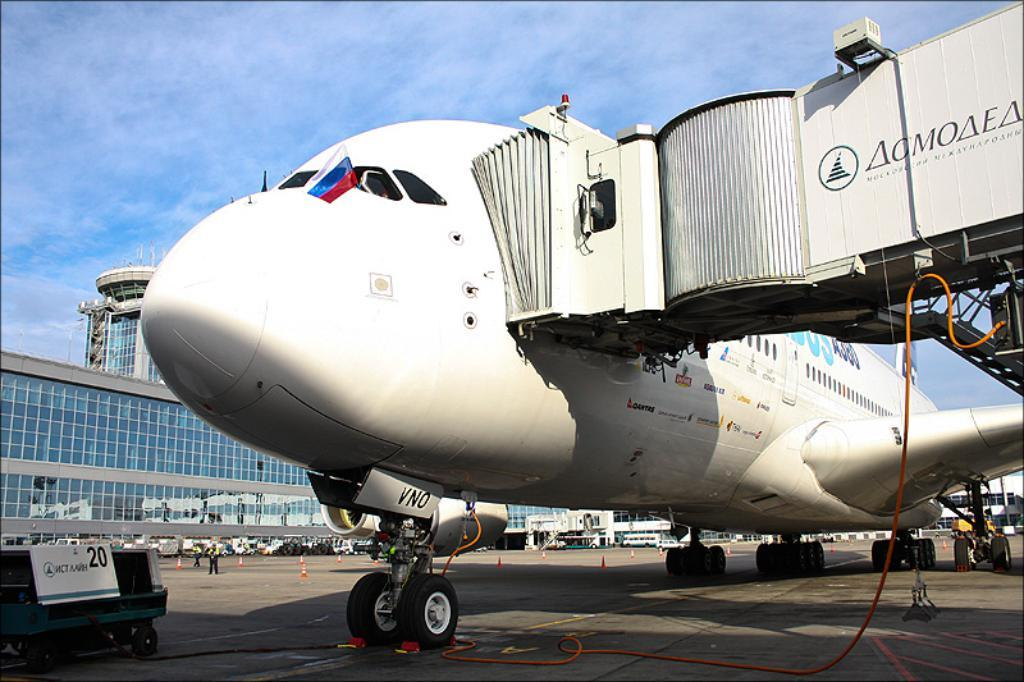What is the main subject of the image? The main subject of the image is a plane on the ground. What can be seen in the background of the image? There are buildings and vehicles visible in the background of the image. Are there any people in the image? Yes, there is a person standing in the image. What type of basketball is the person holding in the image? There is no basketball present in the image; the person is not holding any such object. 